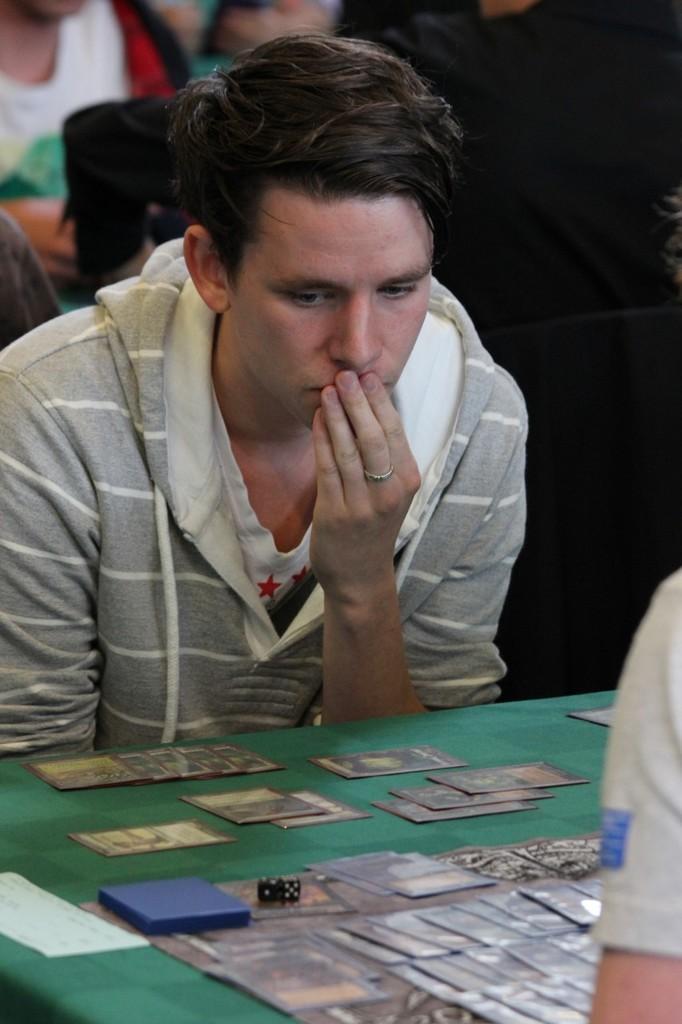How would you summarize this image in a sentence or two? Here we can see a man. This is table. On the table there are cards. On the background we can see some persons. 